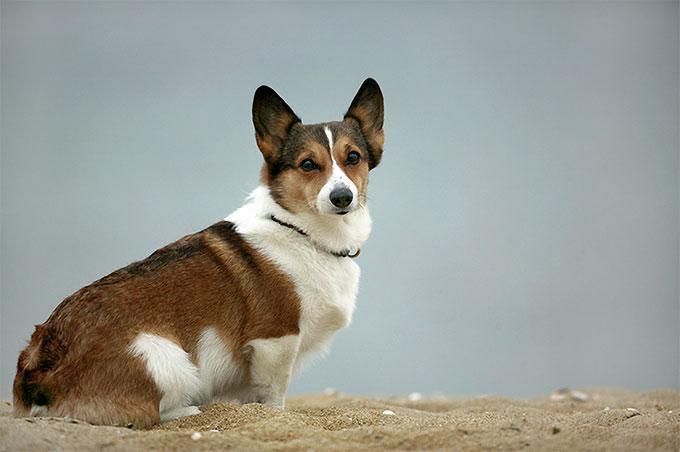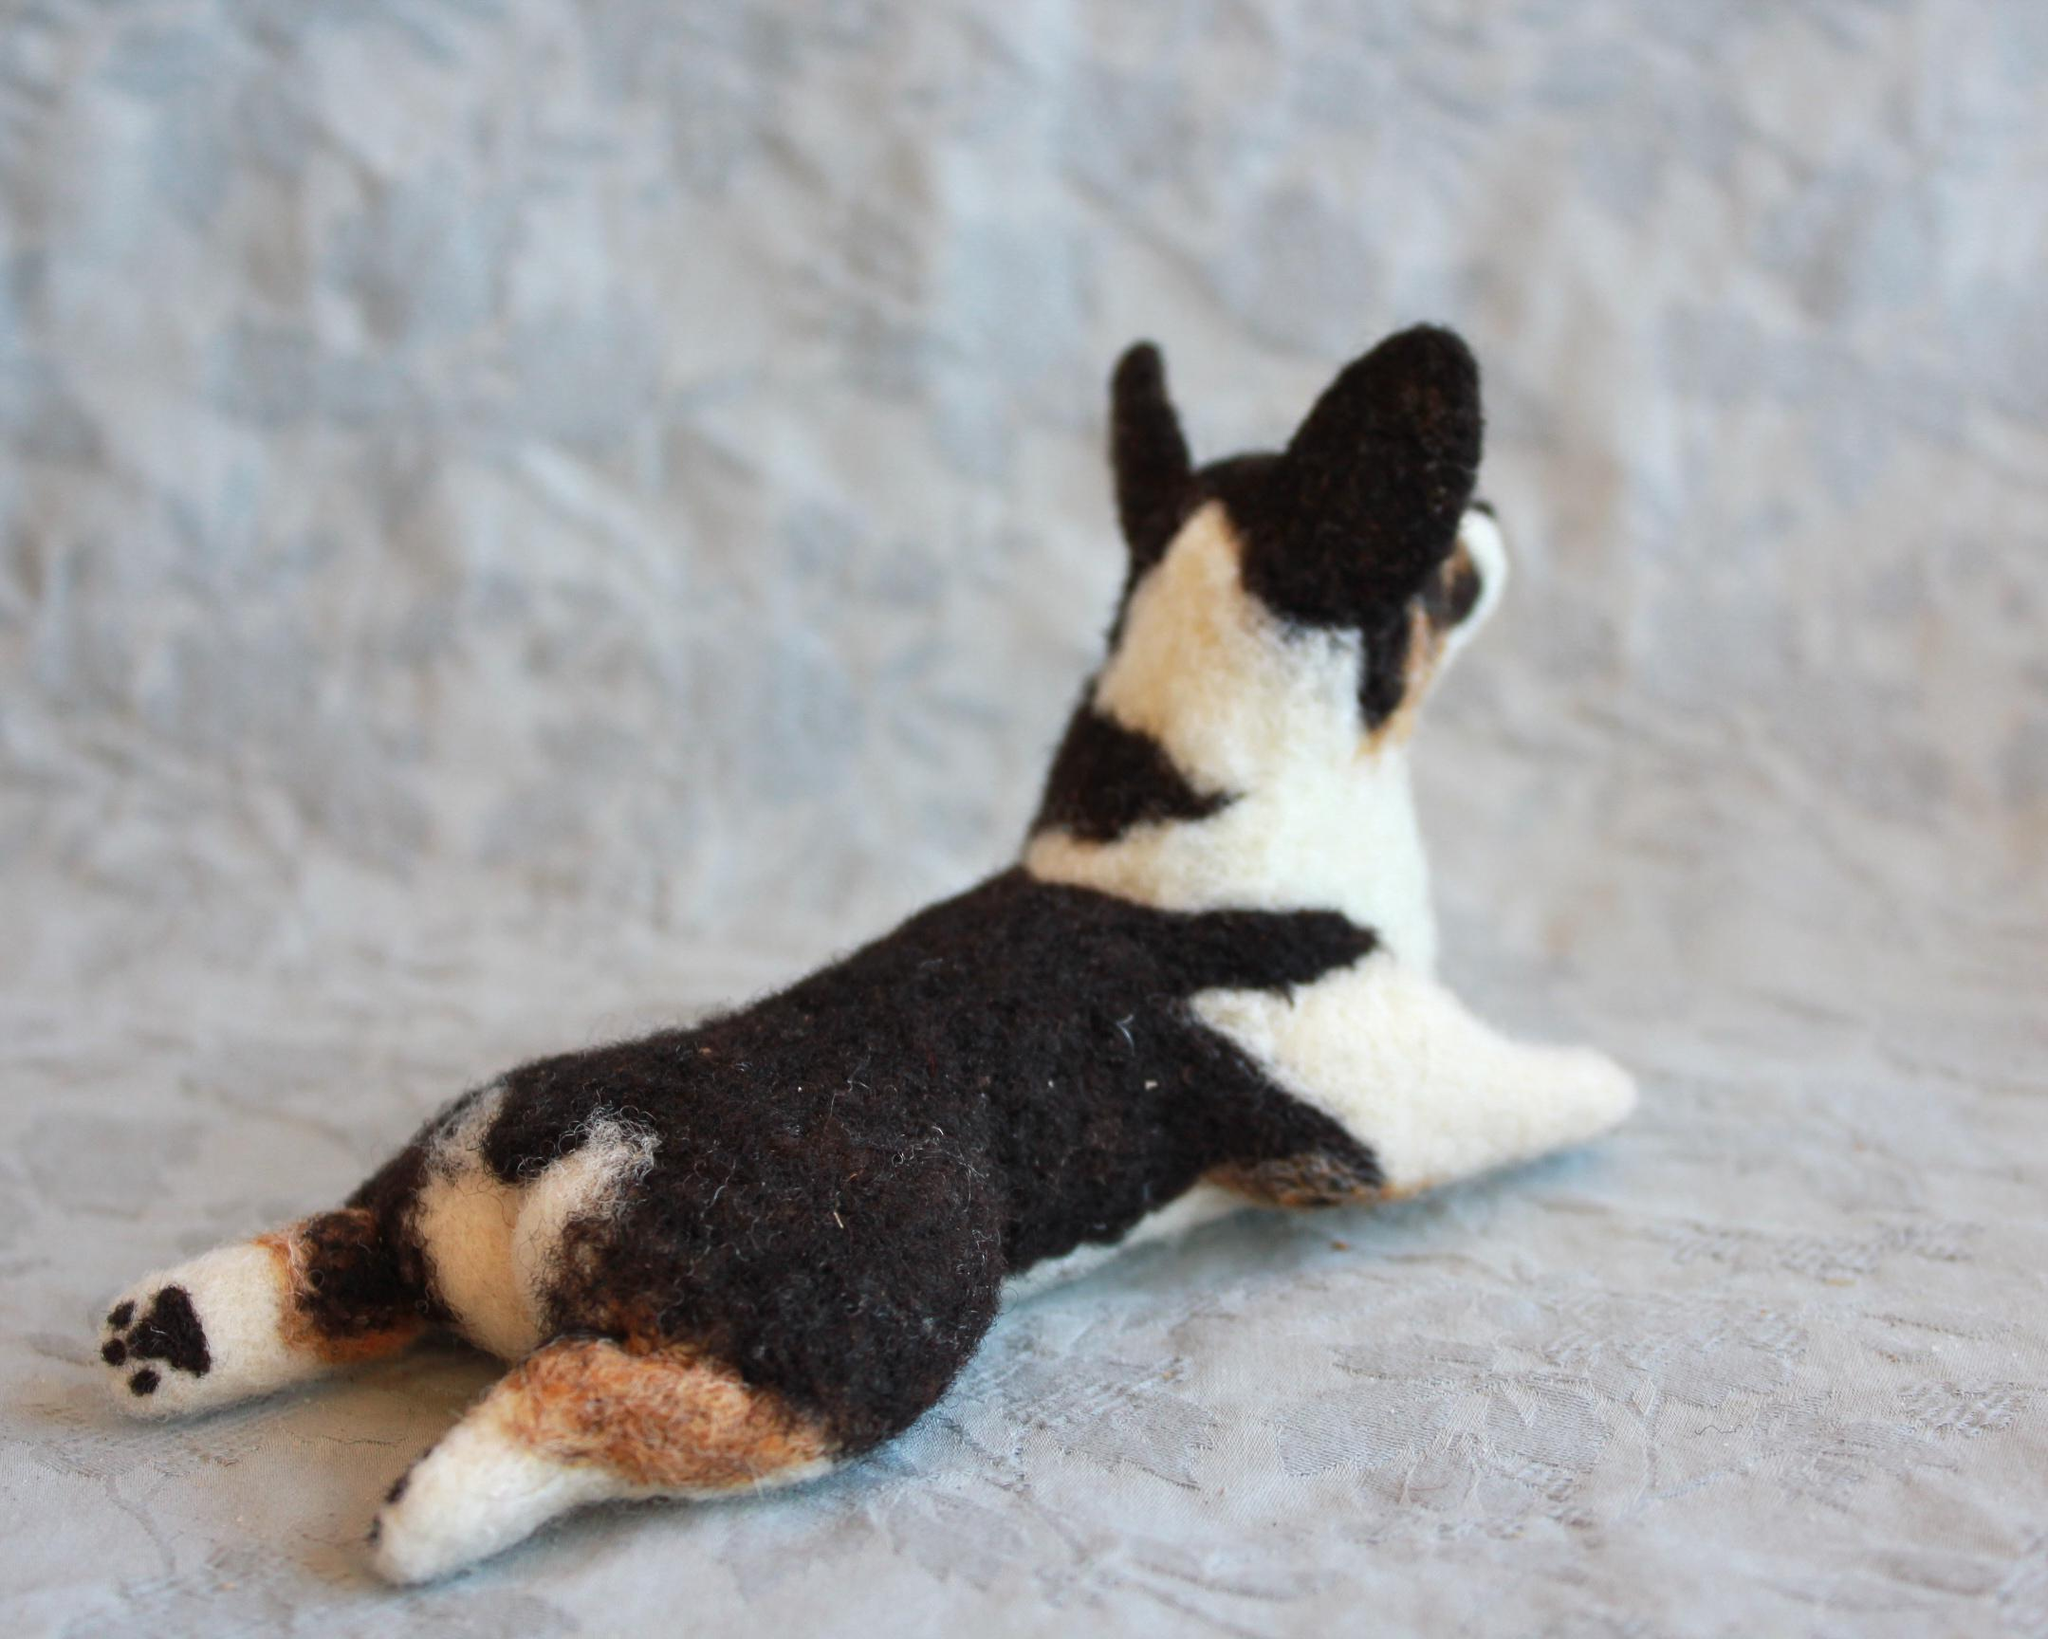The first image is the image on the left, the second image is the image on the right. Examine the images to the left and right. Is the description "There is a sitting dog in one of the images." accurate? Answer yes or no. Yes. 